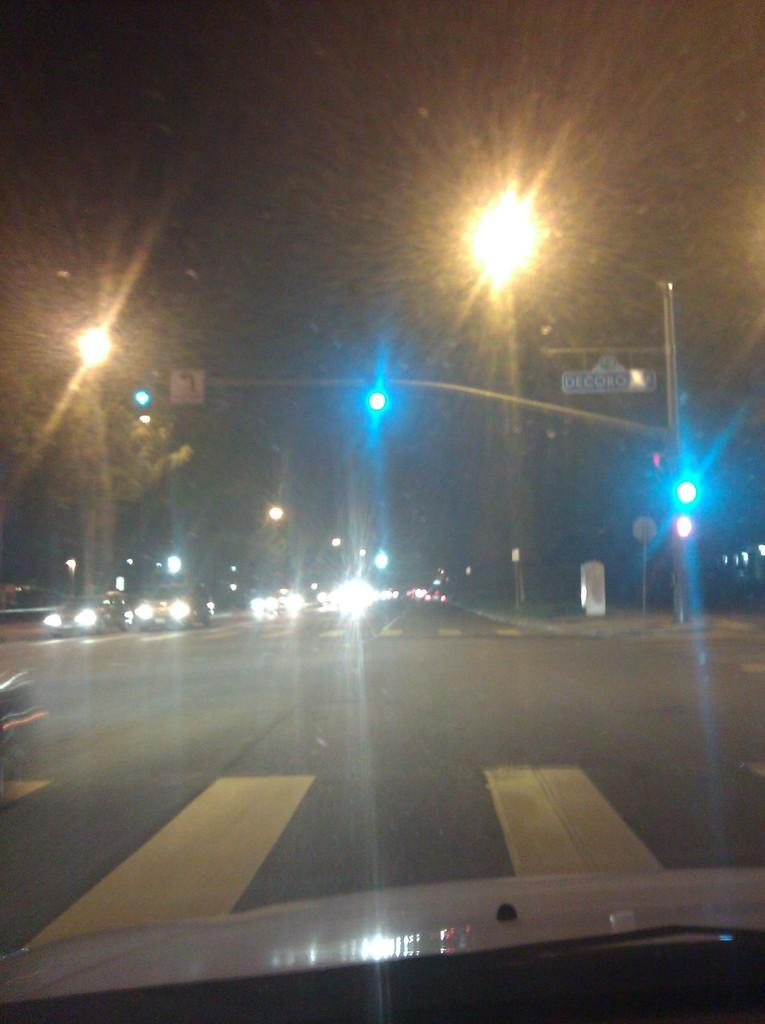What type of vehicle is in the image? There is a vehicle with a front glass in the image. What can be seen through the front glass of the vehicle? Vehicles on the road and street lights are visible through the front glass. What else is visible through the front glass? Poles are visible through the front glass. Can you describe the small board attached to a pole in the image? There is a small board attached to a pole on the right side of the image. What type of sticks are being used to create a flame in the image? There are no sticks or flames present in the image. 